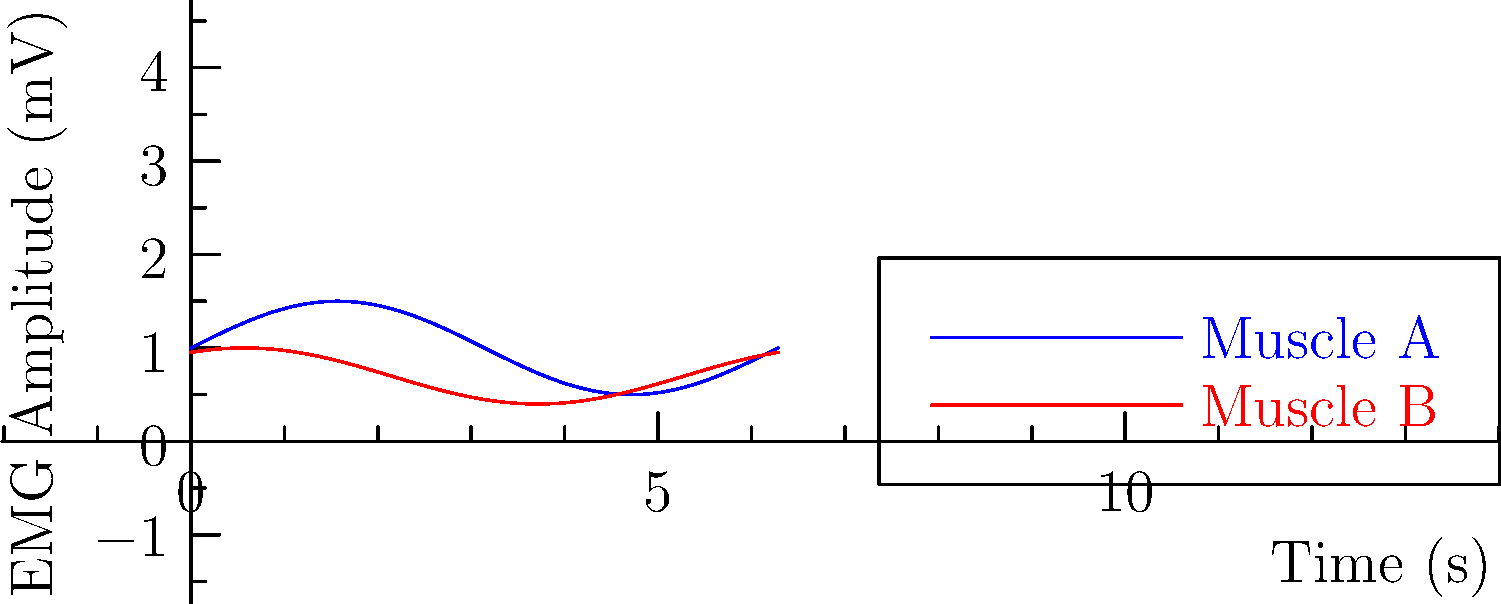Analyze the EMG graphs of Muscle A and Muscle B during a rehabilitation exercise. Which muscle shows higher peak activation, and what does this suggest about the exercise's effectiveness for each muscle? To analyze the EMG graphs and determine which muscle shows higher peak activation:

1. Observe the y-axis: It represents EMG Amplitude in millivolts (mV), indicating muscle activation intensity.

2. Compare the peak amplitudes:
   - Muscle A (blue line): Peak amplitude is approximately 1.5 mV
   - Muscle B (red line): Peak amplitude is approximately 1.0 mV

3. Identify the muscle with higher peak activation:
   Muscle A shows a higher peak activation (1.5 mV > 1.0 mV)

4. Interpret the results:
   - Higher peak activation suggests greater recruitment of motor units and muscle fibers.
   - Muscle A is being more intensely activated during this exercise.

5. Consider the implications for exercise effectiveness:
   - The exercise is more effective at targeting and challenging Muscle A.
   - Muscle B is also activated but to a lesser degree.

6. Rehabilitation considerations:
   - If the goal is to strengthen Muscle A, this exercise is well-suited.
   - For Muscle B, additional or modified exercises may be needed to achieve similar activation levels.

7. Safety and progression:
   - The lower activation of Muscle B may be appropriate if it's recovering from injury.
   - As rehabilitation progresses, exercises can be modified to increase Muscle B activation if needed.
Answer: Muscle A shows higher peak activation, suggesting the exercise is more effective for targeting and strengthening Muscle A compared to Muscle B. 